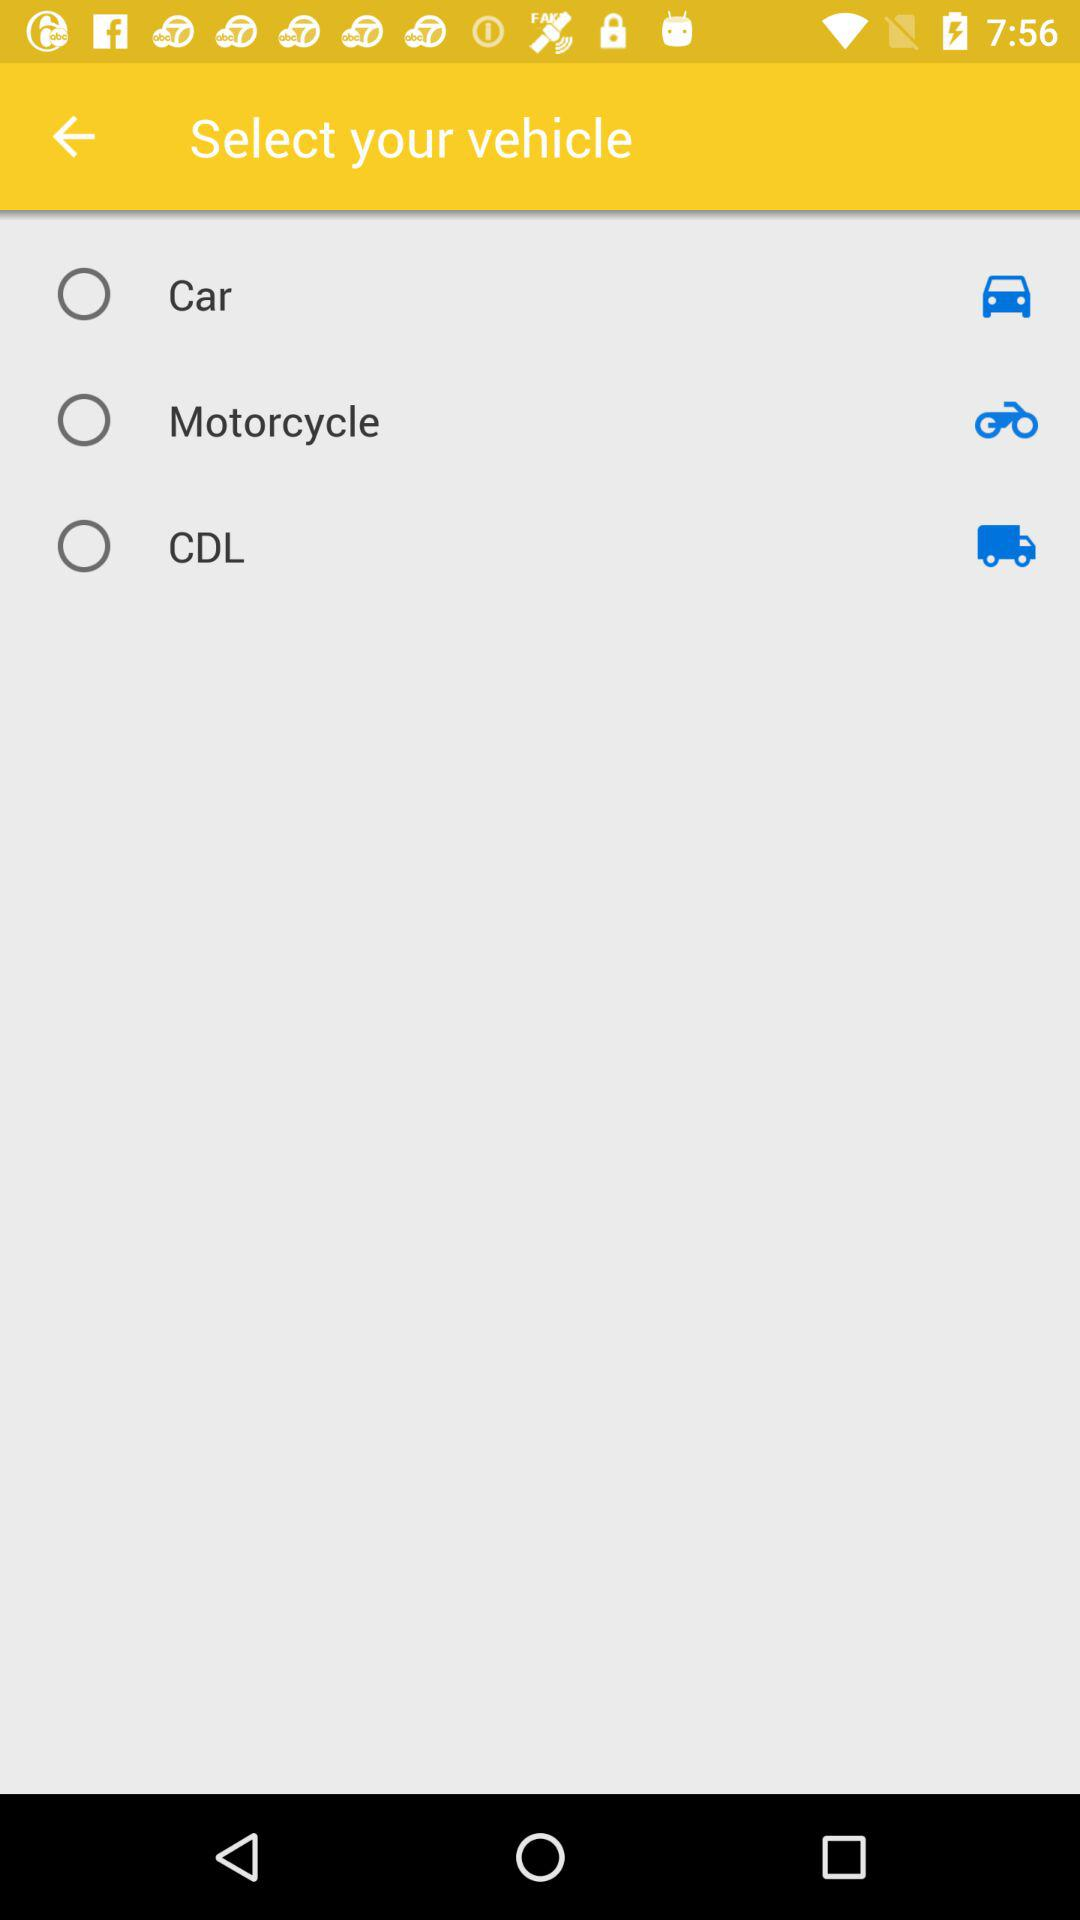How many vehicles are available to select?
Answer the question using a single word or phrase. 3 